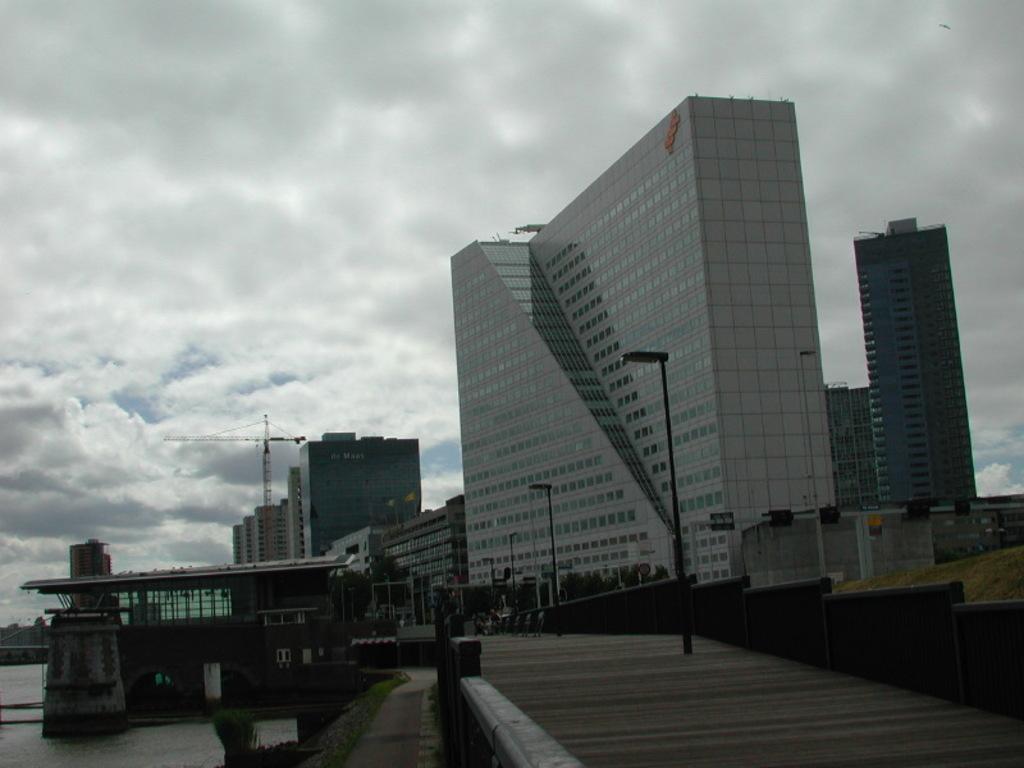Describe this image in one or two sentences. In this image we can see buildings, poles, street lights, construction cranes, ground, water and sky with clouds. 